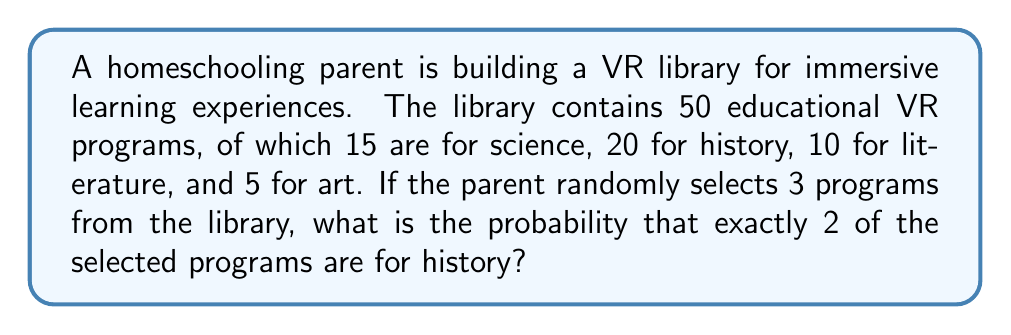Solve this math problem. Let's approach this step-by-step using the concept of combinations:

1) First, we need to calculate the total number of ways to select 3 programs out of 50. This can be done using the combination formula:

   $$\binom{50}{3} = \frac{50!}{3!(50-3)!} = \frac{50!}{3!47!} = 19,600$$

2) Now, we need to calculate the number of ways to select exactly 2 history programs and 1 non-history program:

   a) Select 2 history programs out of 20: $\binom{20}{2} = 190$
   b) Select 1 non-history program out of 30: $\binom{30}{1} = 30$

3) The total number of favorable outcomes is the product of these:

   $190 \times 30 = 5,700$

4) The probability is then the number of favorable outcomes divided by the total number of possible outcomes:

   $$P(\text{exactly 2 history}) = \frac{5,700}{19,600} = \frac{285}{980} \approx 0.2908$$
Answer: The probability of randomly selecting exactly 2 history programs out of 3 selections is $\frac{285}{980}$ or approximately 0.2908 (29.08%). 